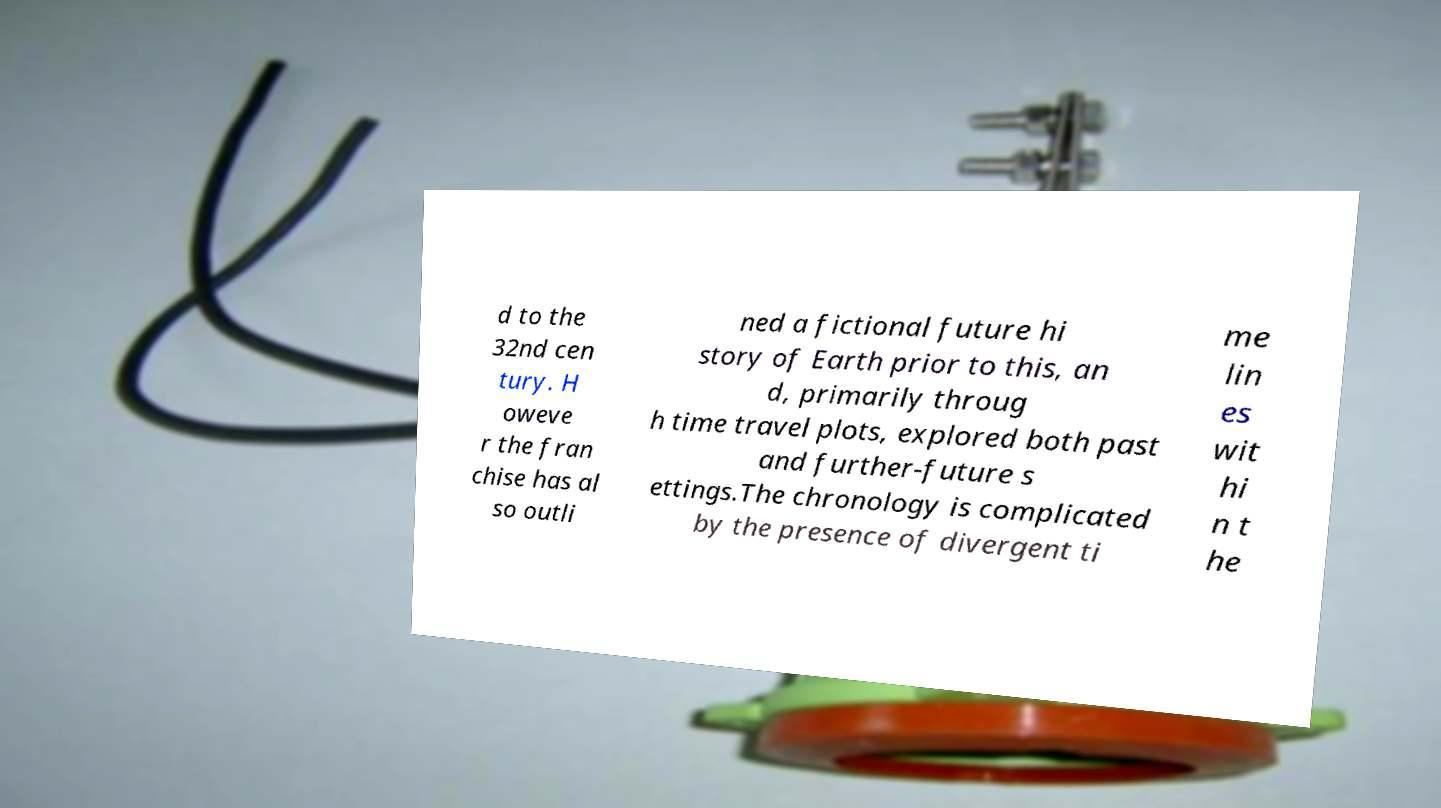There's text embedded in this image that I need extracted. Can you transcribe it verbatim? d to the 32nd cen tury. H oweve r the fran chise has al so outli ned a fictional future hi story of Earth prior to this, an d, primarily throug h time travel plots, explored both past and further-future s ettings.The chronology is complicated by the presence of divergent ti me lin es wit hi n t he 